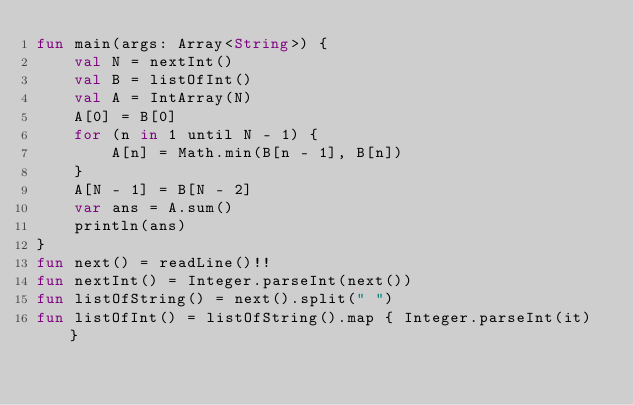<code> <loc_0><loc_0><loc_500><loc_500><_Kotlin_>fun main(args: Array<String>) {
    val N = nextInt()
    val B = listOfInt()
    val A = IntArray(N)
    A[0] = B[0]
    for (n in 1 until N - 1) {
        A[n] = Math.min(B[n - 1], B[n])
    }
    A[N - 1] = B[N - 2]
    var ans = A.sum()
    println(ans)
}
fun next() = readLine()!!
fun nextInt() = Integer.parseInt(next())
fun listOfString() = next().split(" ")
fun listOfInt() = listOfString().map { Integer.parseInt(it) }
</code> 